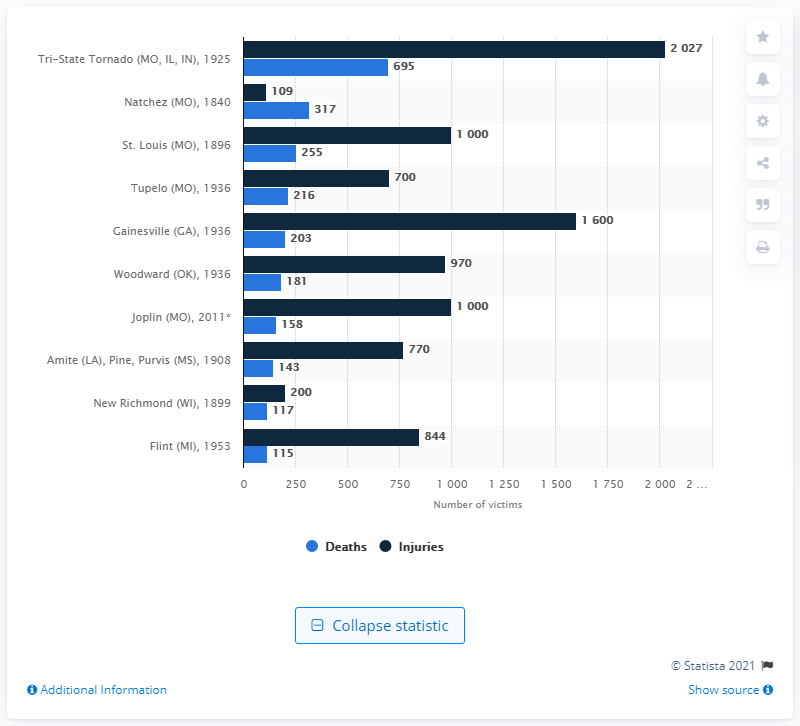Highlight a few significant elements in this photo. A total of 695 people lost their lives in the devastating Tri-State Tornado that struck the Midwest region of the United States on March 18, 1925. If the highest and lowest values in the chart are added, the resulting value is 2142. The highest value in the chart is 2027. 